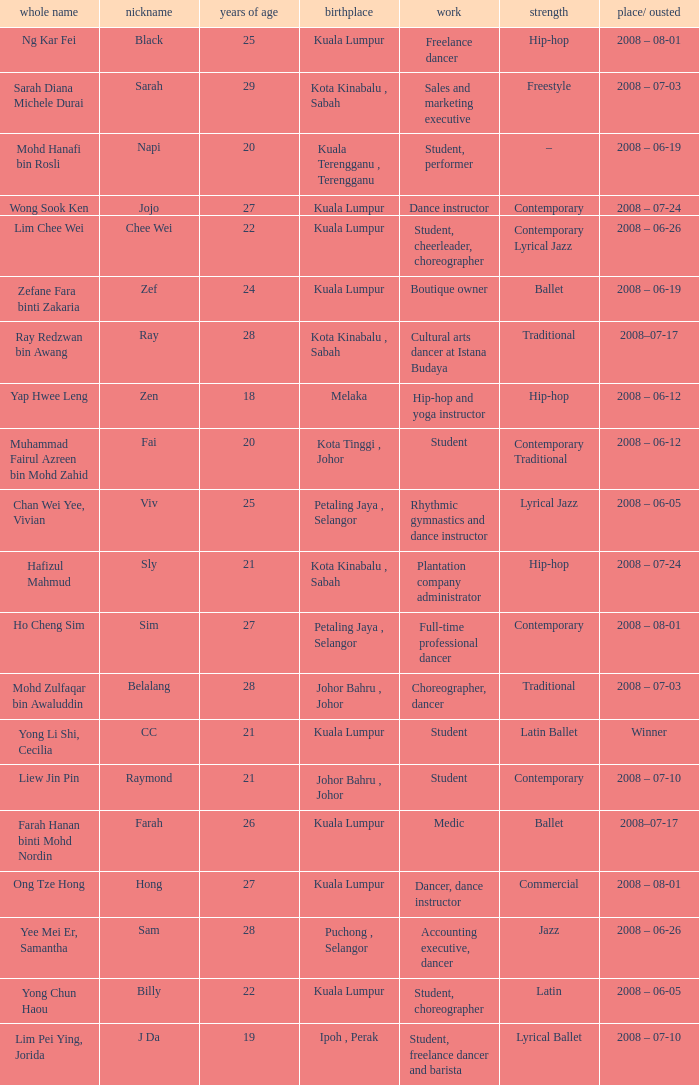What is Position/ Eliminated, when From is "Kuala Lumpur", and when Specialty is "Contemporary Lyrical Jazz"? 2008 – 06-26. 